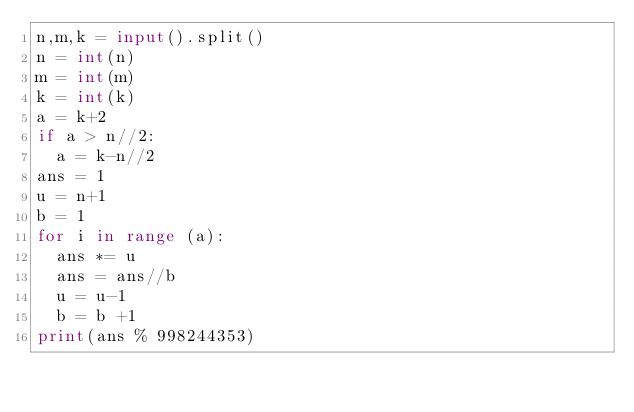Convert code to text. <code><loc_0><loc_0><loc_500><loc_500><_Python_>n,m,k = input().split()
n = int(n)
m = int(m)
k = int(k)
a = k+2
if a > n//2: 
  a = k-n//2
ans = 1
u = n+1
b = 1
for i in range (a):
  ans *= u
  ans = ans//b
  u = u-1
  b = b +1
print(ans % 998244353)</code> 